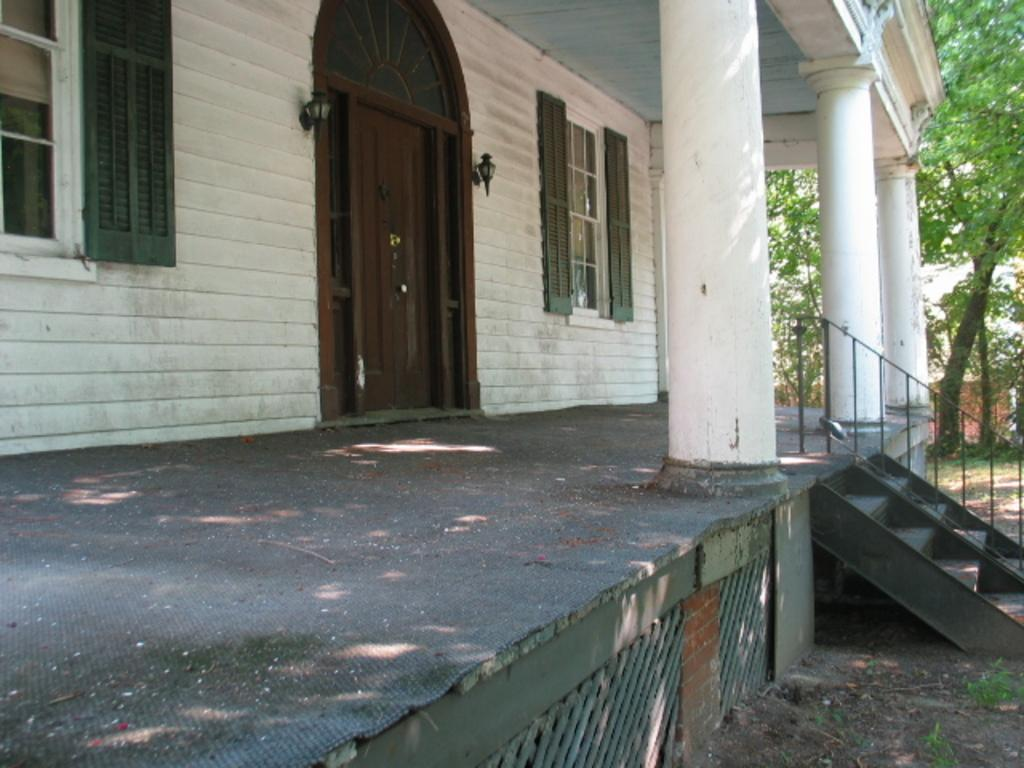What type of structure is visible in the image? There is a building in the image. What are the main features of the building? The building has walls, windows, doors, and pillars. What architectural elements are present in front of the building? There are steps and railings in front of the building. What can be seen in the background of the image? There are trees in the background of the image. What type of ball is being used to play a game in front of the building? There is no ball present in the image; it only shows a building with steps and railings in front, and trees in the background. 